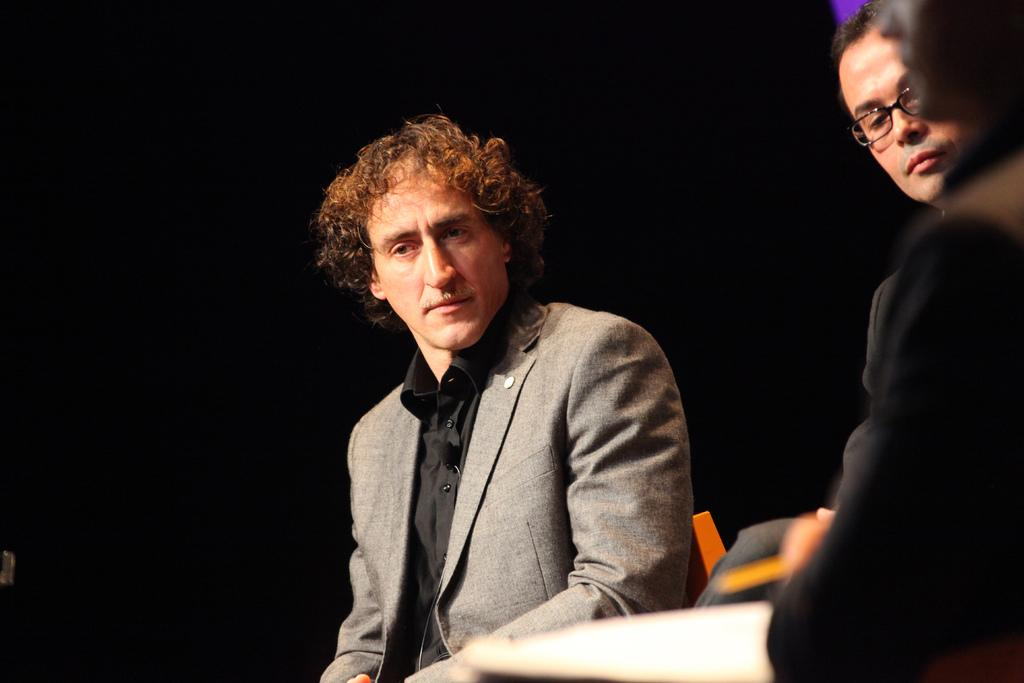How many people are visible on the right side of the image? There are two persons on the right side of the image. What is the man in the middle of the image doing? The man is sitting on a chair in the middle of the image. What color is the background of the image? The background of the image appears to be black. What type of frame is the sun placed in within the image? There is no sun present in the image, so there is no frame for it. How do the two persons on the right side of the image say good-bye to each other in the image? There is no indication of the two persons saying good-bye to each other in the image. 